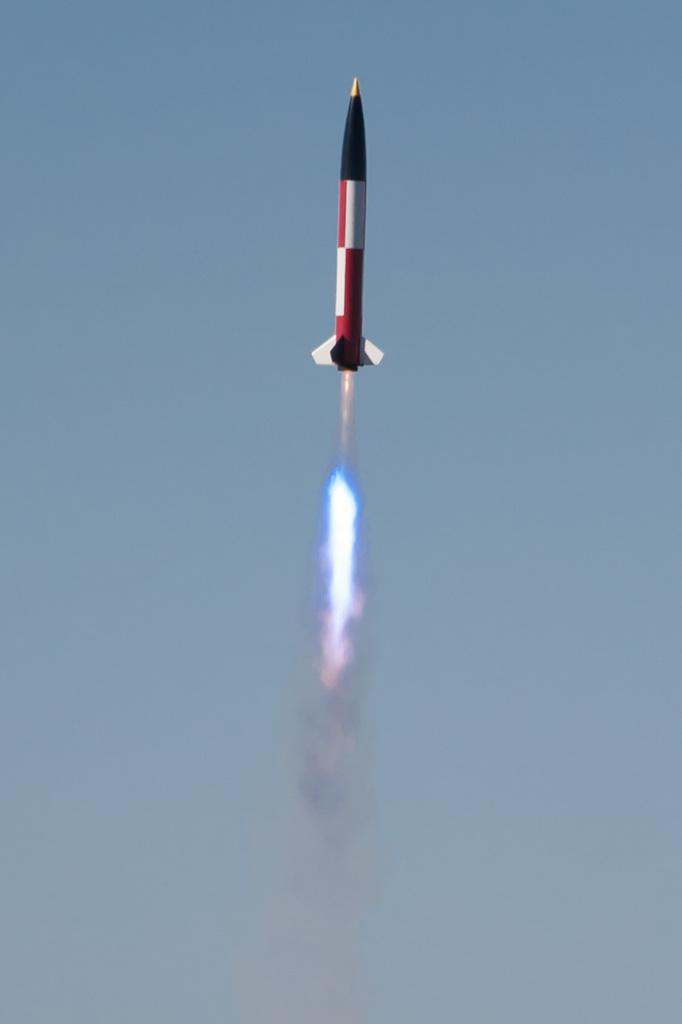What is the main subject of the image? There is a rocket in the image. What is happening to the rocket in the image? The rocket is emitting fire and smoke, and it is flying in the air. What can be seen in the background of the image? There is a blue sky in the background of the image. What type of bat can be seen flying near the rocket in the image? There is no bat present in the image; it only features a rocket flying in the air. What type of blood vessels can be seen in the rocket's system in the image? There is no mention of a rocket system or blood vessels in the image; it only shows a rocket emitting fire and smoke while flying in the air. 